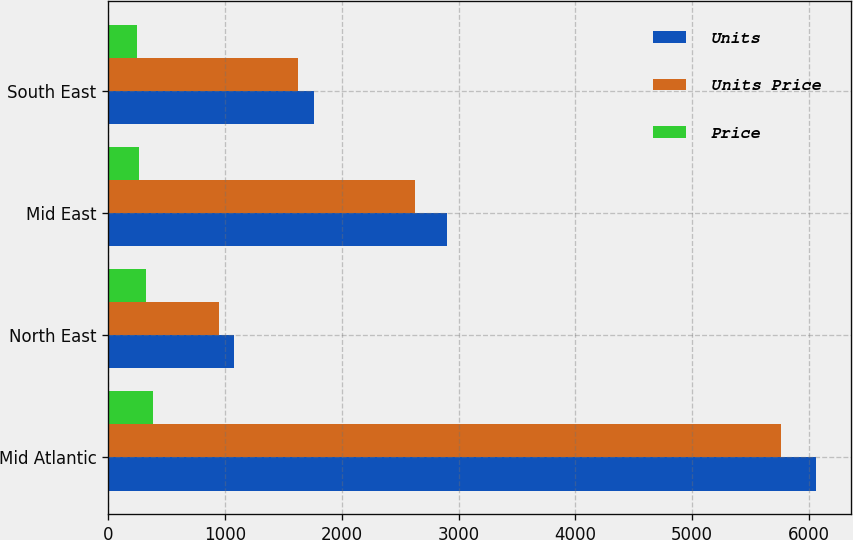<chart> <loc_0><loc_0><loc_500><loc_500><stacked_bar_chart><ecel><fcel>Mid Atlantic<fcel>North East<fcel>Mid East<fcel>South East<nl><fcel>Units<fcel>6056<fcel>1075<fcel>2903<fcel>1766<nl><fcel>Units Price<fcel>5757<fcel>946<fcel>2625<fcel>1626<nl><fcel>Price<fcel>382.9<fcel>325.3<fcel>264.2<fcel>243.7<nl></chart> 